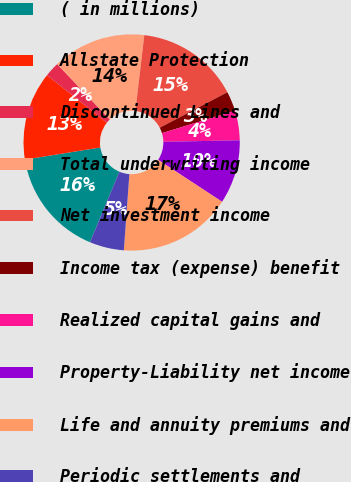Convert chart. <chart><loc_0><loc_0><loc_500><loc_500><pie_chart><fcel>( in millions)<fcel>Allstate Protection<fcel>Discontinued Lines and<fcel>Total underwriting income<fcel>Net investment income<fcel>Income tax (expense) benefit<fcel>Realized capital gains and<fcel>Property-Liability net income<fcel>Life and annuity premiums and<fcel>Periodic settlements and<nl><fcel>16.17%<fcel>13.23%<fcel>2.21%<fcel>13.97%<fcel>15.44%<fcel>2.95%<fcel>4.42%<fcel>9.56%<fcel>16.91%<fcel>5.15%<nl></chart> 